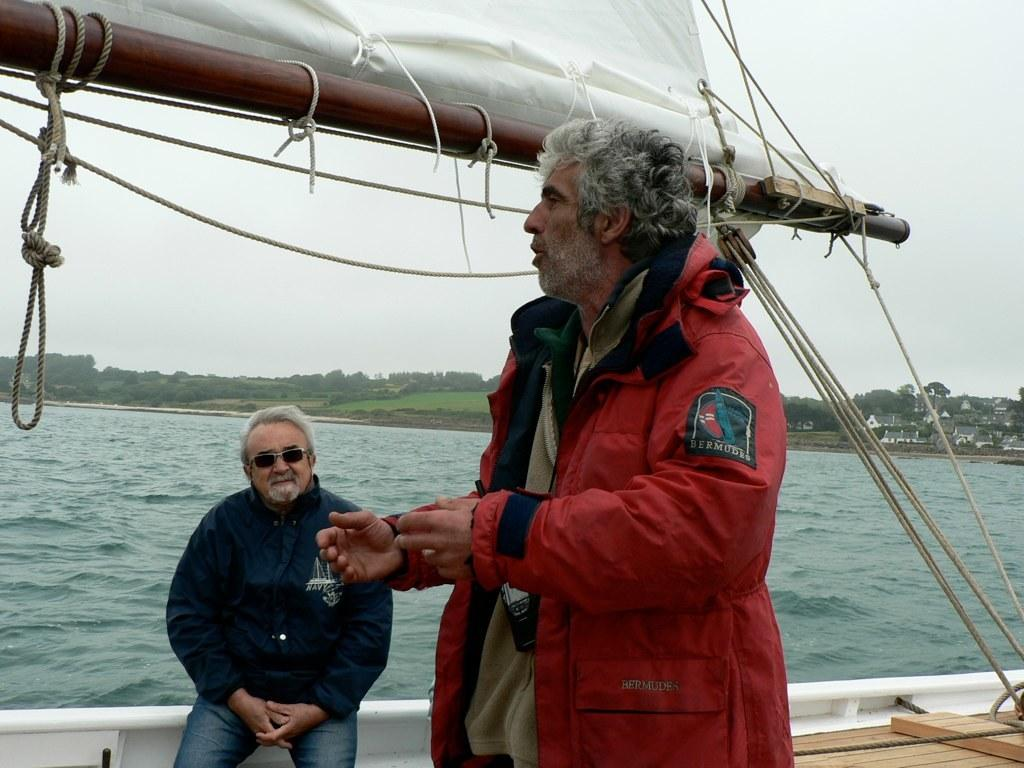<image>
Share a concise interpretation of the image provided. A sailboat with two man one with red coat made by Bermudes. 